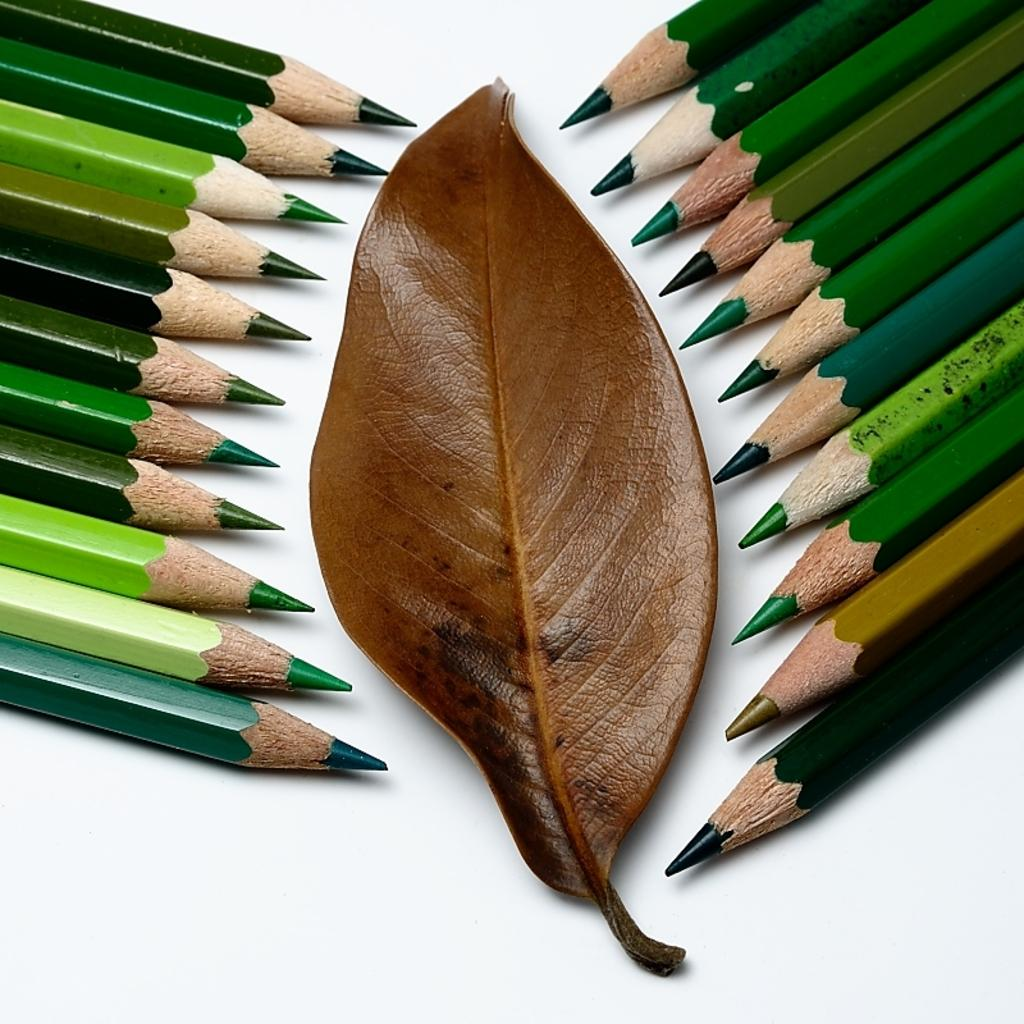What stationery items can be seen in the image? There are color pencils in the image. What natural element is present in the image? There is a leaf in the image. On what surface is the leaf placed? The leaf is on a white surface. What type of lock is securing the color pencils in the image? There is no lock present in the image; the color pencils are not secured. How many points does the leaf have in the image? The number of points on the leaf cannot be determined from the image alone, as it depends on the type of leaf and its condition. 